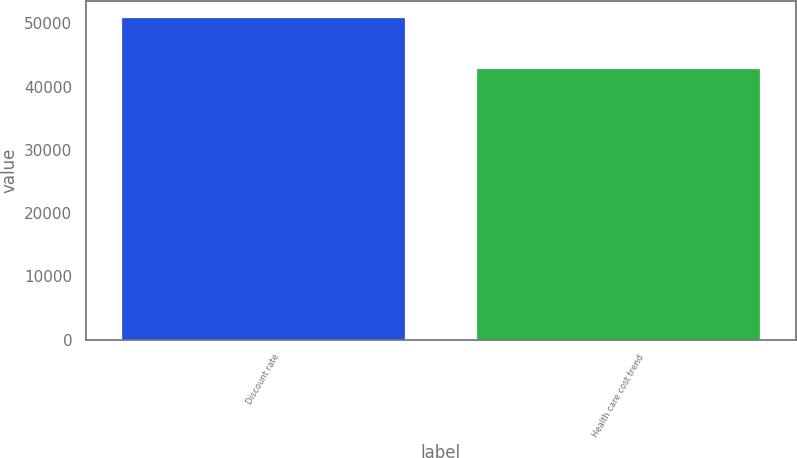Convert chart to OTSL. <chart><loc_0><loc_0><loc_500><loc_500><bar_chart><fcel>Discount rate<fcel>Health care cost trend<nl><fcel>50925<fcel>42890<nl></chart> 